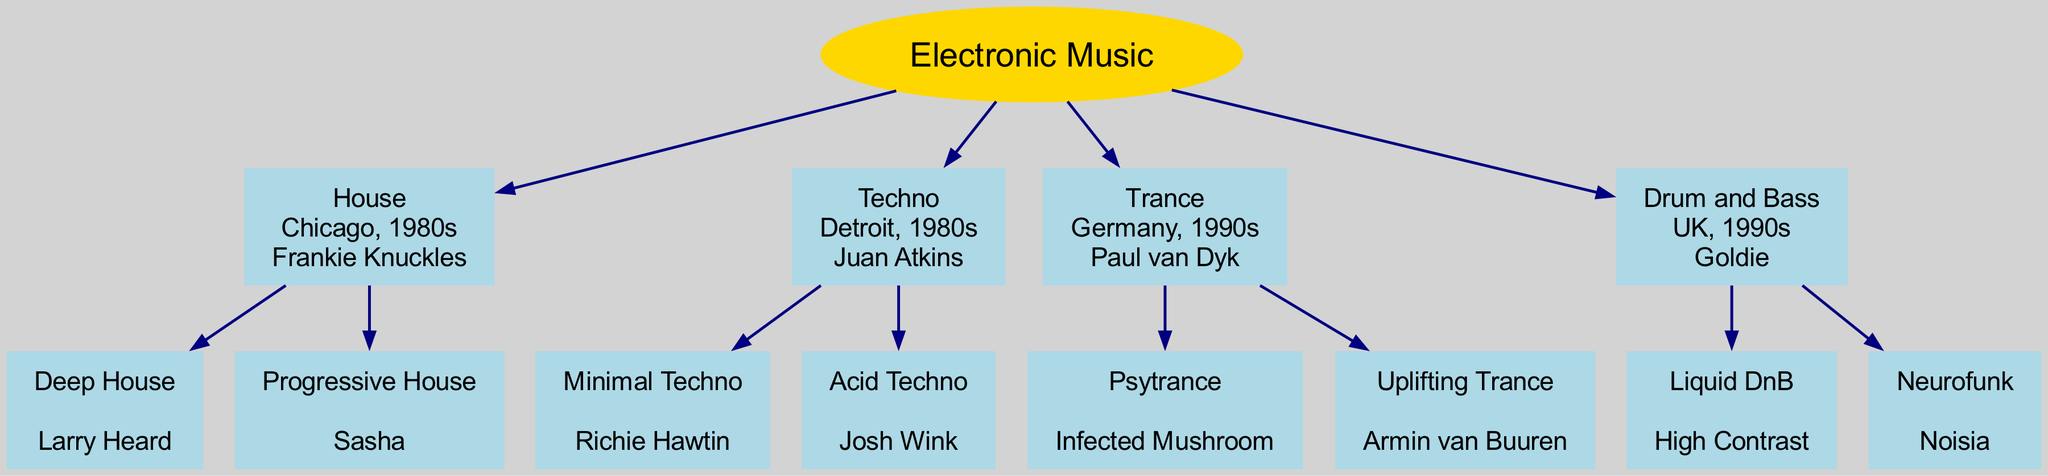What is the root of the family tree? The root of the family tree is the main title that represents the overall theme of the diagram, which in this case is "Electronic Music."
Answer: Electronic Music Which genre originated in Chicago during the 1980s? By examining the information about the origins of the genres, we see that House originated in Chicago during the 1980s.
Answer: House Who is the artist associated with Deep House? Deep House is listed as a child genre under House, and the artist associated with it is Larry Heard.
Answer: Larry Heard How many main genres are displayed in the diagram? The main genres displayed in the diagram are House, Techno, Trance, and Drum and Bass, so we count a total of four.
Answer: 4 Which genre is a subgenre of Techno? By looking at the children of the Techno genre, we find Minimal Techno and Acid Techno; either can be considered the answer.
Answer: Minimal Techno (or Acid Techno) What is the origin of Trance? Trance is noted as having originated in Germany during the 1990s according to the diagram.
Answer: Germany, 1990s Which artist is listed as the originator of Drum and Bass? The artist identified with the origin of Drum and Bass is Goldie, as per the information in the diagram.
Answer: Goldie What genre is a subgenre of Trance and what artist is associated with it? The subgenre of Trance indicated in the diagram is Psytrance, and it is associated with the artist Infected Mushroom.
Answer: Psytrance, Infected Mushroom Which subgenre of House has Larry Heard as its artist? Looking closer at the diagram, Deep House lists Larry Heard as its artist, making it the answer to the question.
Answer: Deep House 